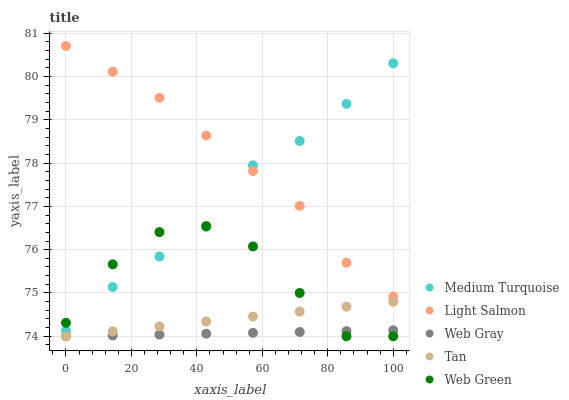Does Web Gray have the minimum area under the curve?
Answer yes or no. Yes. Does Light Salmon have the maximum area under the curve?
Answer yes or no. Yes. Does Light Salmon have the minimum area under the curve?
Answer yes or no. No. Does Web Gray have the maximum area under the curve?
Answer yes or no. No. Is Tan the smoothest?
Answer yes or no. Yes. Is Web Green the roughest?
Answer yes or no. Yes. Is Light Salmon the smoothest?
Answer yes or no. No. Is Light Salmon the roughest?
Answer yes or no. No. Does Web Green have the lowest value?
Answer yes or no. Yes. Does Light Salmon have the lowest value?
Answer yes or no. No. Does Light Salmon have the highest value?
Answer yes or no. Yes. Does Web Gray have the highest value?
Answer yes or no. No. Is Web Green less than Light Salmon?
Answer yes or no. Yes. Is Light Salmon greater than Tan?
Answer yes or no. Yes. Does Medium Turquoise intersect Web Green?
Answer yes or no. Yes. Is Medium Turquoise less than Web Green?
Answer yes or no. No. Is Medium Turquoise greater than Web Green?
Answer yes or no. No. Does Web Green intersect Light Salmon?
Answer yes or no. No. 